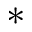Convert formula to latex. <formula><loc_0><loc_0><loc_500><loc_500>*</formula> 